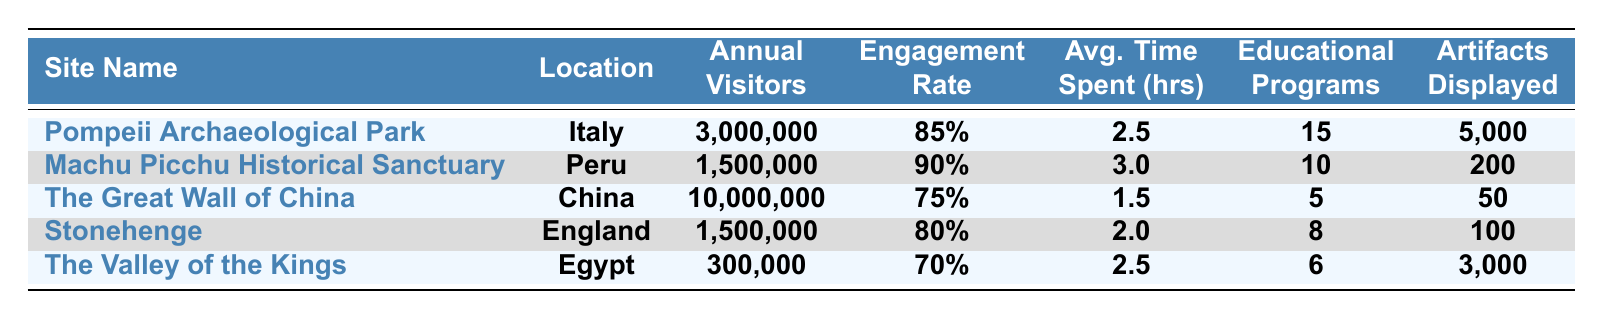What is the location of the "Valley of the Kings"? The table lists the location corresponding to "The Valley of the Kings" as Egypt.
Answer: Egypt How many educational programs are offered at Machu Picchu Historical Sanctuary? The table shows that Machu Picchu Historical Sanctuary offers 10 educational programs.
Answer: 10 Which site has the highest annual visitors? By comparing the annual visitor numbers, The Great Wall of China has 10,000,000 annual visitors, the highest in the table.
Answer: The Great Wall of China What is the average time spent at the Pompeii Archaeological Park? According to the table, the average time spent at Pompeii Archaeological Park is 2.5 hours.
Answer: 2.5 hours How many total annual visitors do Pompeii Archaeological Park and Stonehenge have combined? Adding the annual visitors for both sites gives: 3,000,000 (Pompeii) + 1,500,000 (Stonehenge) = 4,500,000.
Answer: 4,500,000 Is the engagement rate at The Valley of the Kings higher than 75%? The engagement rate at The Valley of the Kings is 70%, which is less than 75%. Therefore, the statement is false.
Answer: No Which site has the lowest engagement rate? The table provides the engagement rates, revealing that The Valley of the Kings, at 70%, has the lowest engagement rate.
Answer: The Valley of the Kings What is the difference in average time spent between the Great Wall of China and Machu Picchu Historical Sanctuary? The average times are 1.5 hours (Great Wall) and 3 hours (Machu Picchu). The difference is 3 - 1.5 = 1.5 hours.
Answer: 1.5 hours How many artifacts are displayed at Stonehenge compared to Machu Picchu? Stonehenge has 100 artifacts displayed, while Machu Picchu displays 200 artifacts. The difference is 200 - 100 = 100.
Answer: 100 fewer artifacts at Stonehenge If you add the annual visitors of all the sites, what would that total be? Adding the annual visitors: 3,000,000 (Pompeii) + 1,500,000 (Machu Picchu) + 10,000,000 (Great Wall) + 1,500,000 (Stonehenge) + 300,000 (Valley of the Kings) equals 16,300,000.
Answer: 16,300,000 What is the engagement rate for sites that display more than 2,000 artifacts? Only Pompeii (5,000 artifacts) and the Valley of the Kings (3,000 artifacts) display more than 2,000 artifacts. Their engagement rates are 85% and 70%, respectively. The average is (85% + 70%)/2 = 77.5%.
Answer: 77.5% 